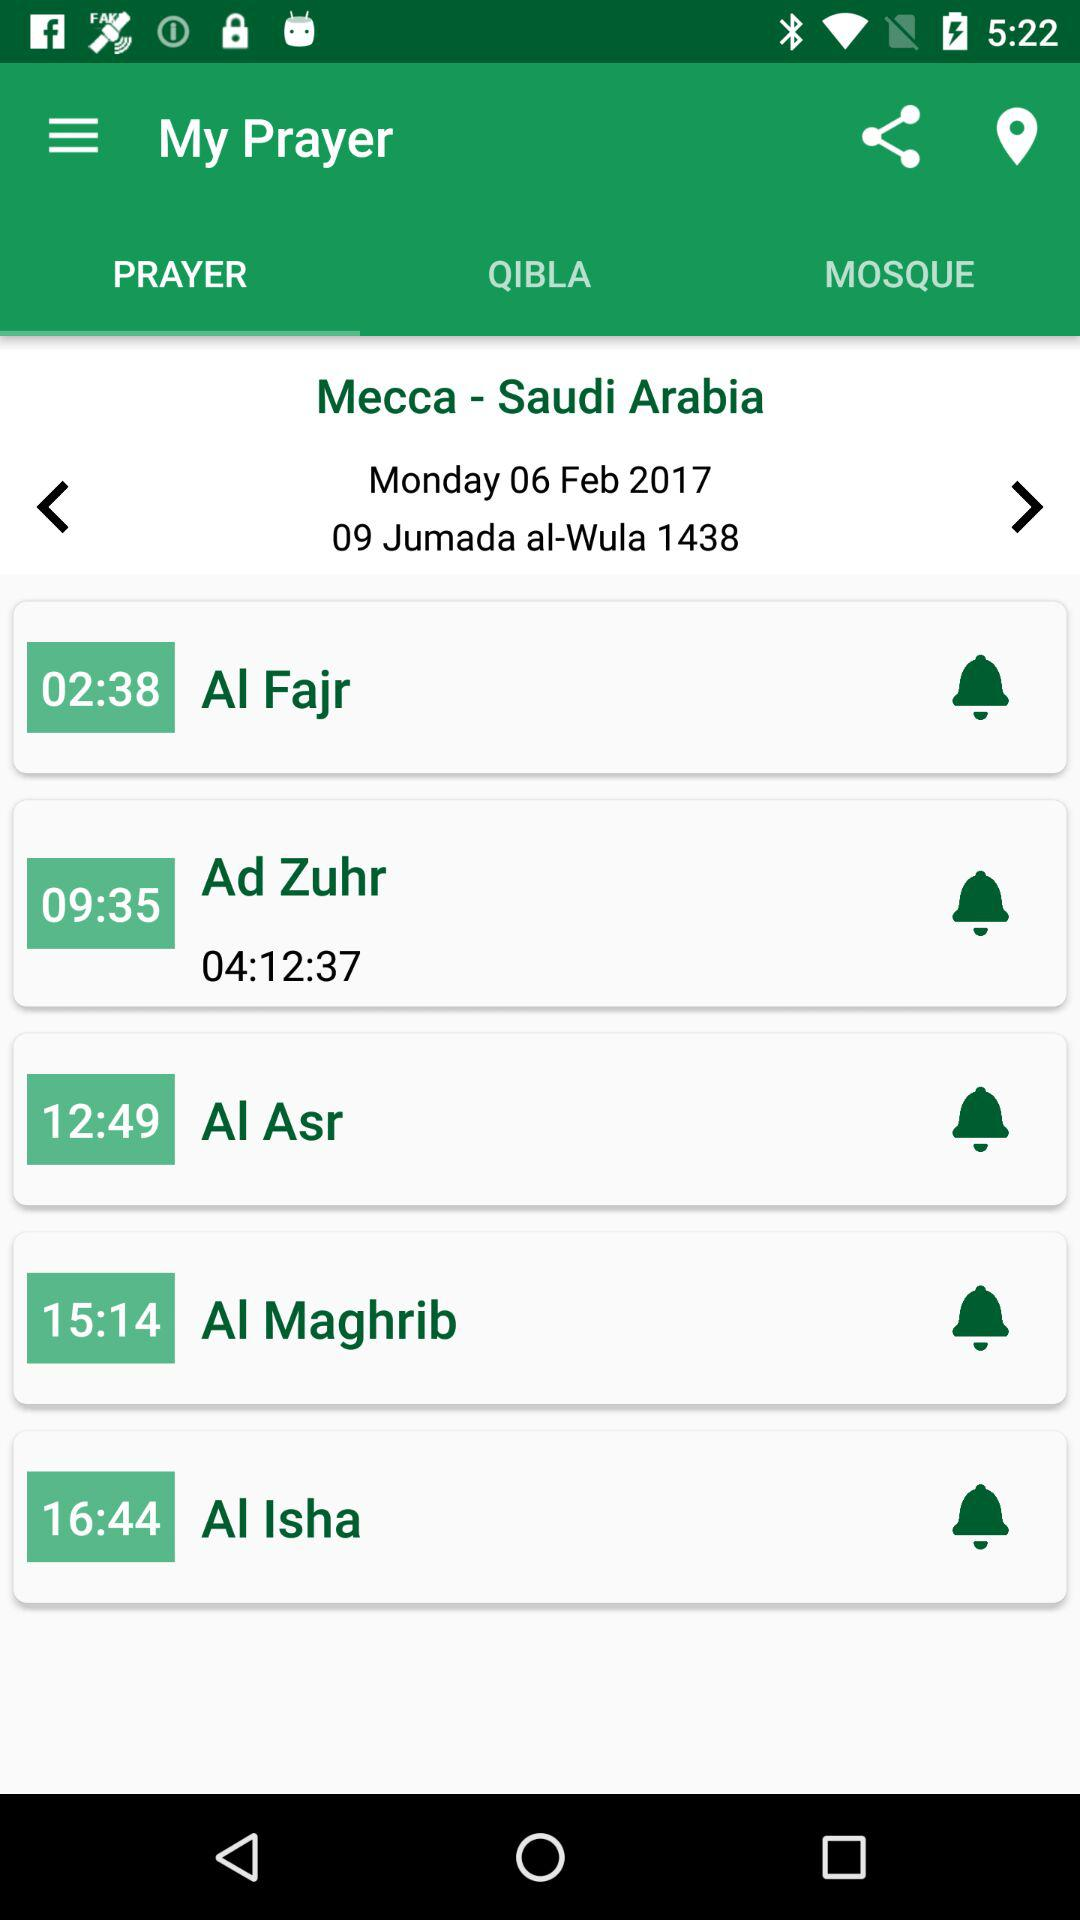How many prayer times are there?
Answer the question using a single word or phrase. 5 